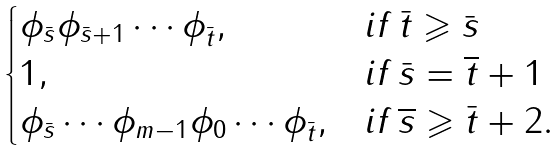<formula> <loc_0><loc_0><loc_500><loc_500>\begin{cases} \phi _ { \bar { s } } \phi _ { \bar { s } + 1 } \cdots \phi _ { \bar { t } } , & i f \, \bar { t } \geqslant \bar { s } \\ 1 , & i f \, \bar { s } = \overline { t } + 1 \\ \phi _ { \bar { s } } \cdots \phi _ { m - 1 } \phi _ { 0 } \cdots \phi _ { \bar { t } } , & i f \, \overline { s } \geqslant \bar { t } + 2 . \end{cases}</formula> 